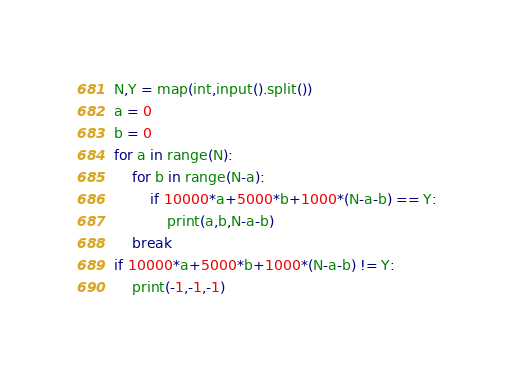Convert code to text. <code><loc_0><loc_0><loc_500><loc_500><_Python_>N,Y = map(int,input().split())
a = 0
b = 0
for a in range(N):
	for b in range(N-a):
		if 10000*a+5000*b+1000*(N-a-b) == Y:
			print(a,b,N-a-b)
	break	
if 10000*a+5000*b+1000*(N-a-b) != Y:
	print(-1,-1,-1)
</code> 